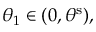Convert formula to latex. <formula><loc_0><loc_0><loc_500><loc_500>\theta _ { 1 } \in ( 0 , \theta ^ { s } ) ,</formula> 